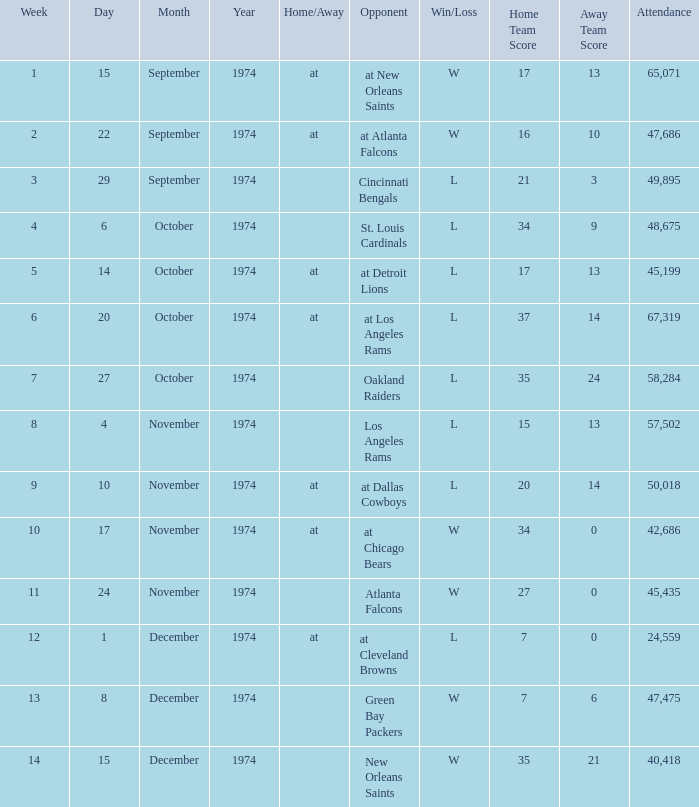What was the attendance when they played at Detroit Lions? 45199.0. 